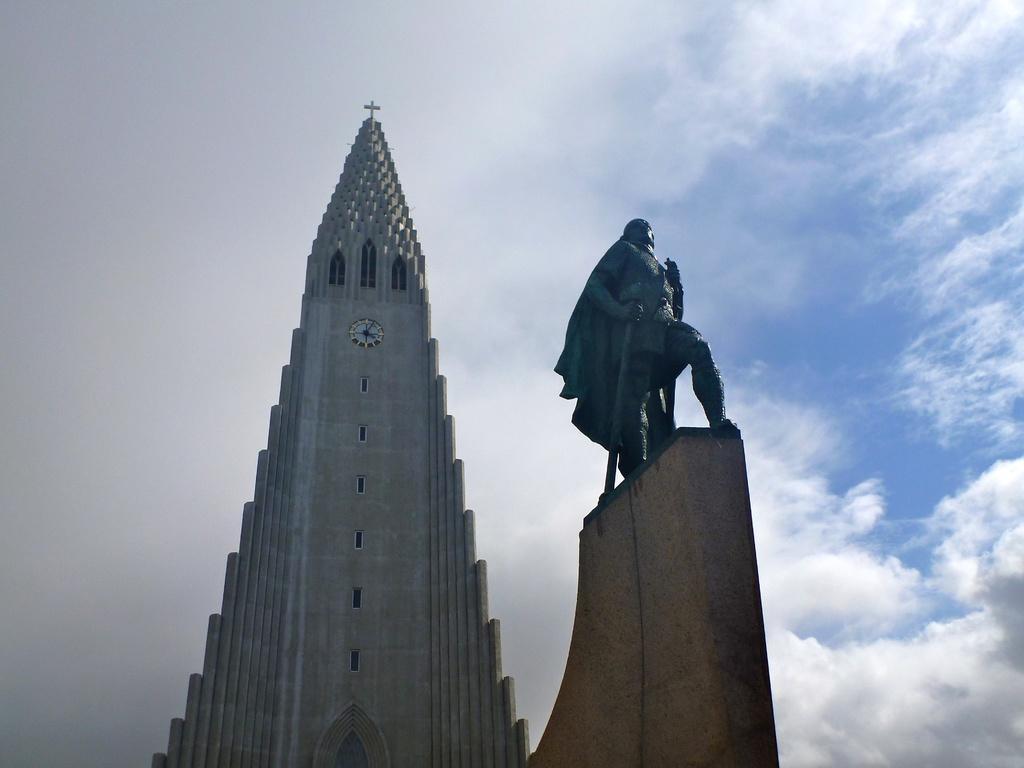Describe this image in one or two sentences. There is a church it is very gigantic and on the top of the church there is a clock in between, on the right side there is a tall sculpture of a warrior. 